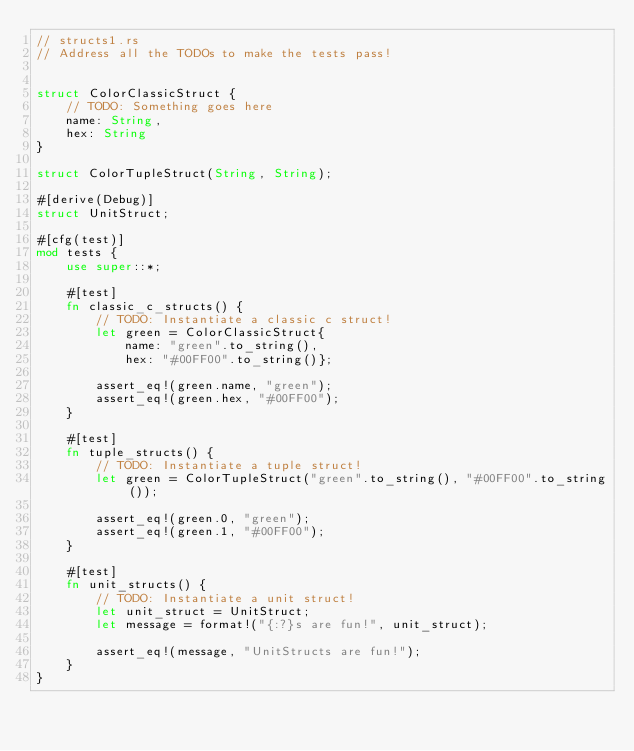Convert code to text. <code><loc_0><loc_0><loc_500><loc_500><_Rust_>// structs1.rs
// Address all the TODOs to make the tests pass!


struct ColorClassicStruct {
    // TODO: Something goes here
    name: String, 
    hex: String
}

struct ColorTupleStruct(String, String);

#[derive(Debug)]
struct UnitStruct;

#[cfg(test)]
mod tests {
    use super::*;

    #[test]
    fn classic_c_structs() {
        // TODO: Instantiate a classic c struct!
        let green = ColorClassicStruct{
            name: "green".to_string(), 
            hex: "#00FF00".to_string()};

        assert_eq!(green.name, "green");
        assert_eq!(green.hex, "#00FF00");
    }

    #[test]
    fn tuple_structs() {
        // TODO: Instantiate a tuple struct!
        let green = ColorTupleStruct("green".to_string(), "#00FF00".to_string());

        assert_eq!(green.0, "green");
        assert_eq!(green.1, "#00FF00");
    }

    #[test]
    fn unit_structs() {
        // TODO: Instantiate a unit struct!
        let unit_struct = UnitStruct; 
        let message = format!("{:?}s are fun!", unit_struct);

        assert_eq!(message, "UnitStructs are fun!");
    }
}
</code> 